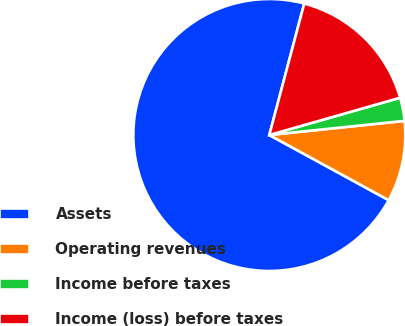Convert chart. <chart><loc_0><loc_0><loc_500><loc_500><pie_chart><fcel>Assets<fcel>Operating revenues<fcel>Income before taxes<fcel>Income (loss) before taxes<nl><fcel>71.18%<fcel>9.61%<fcel>2.76%<fcel>16.45%<nl></chart> 